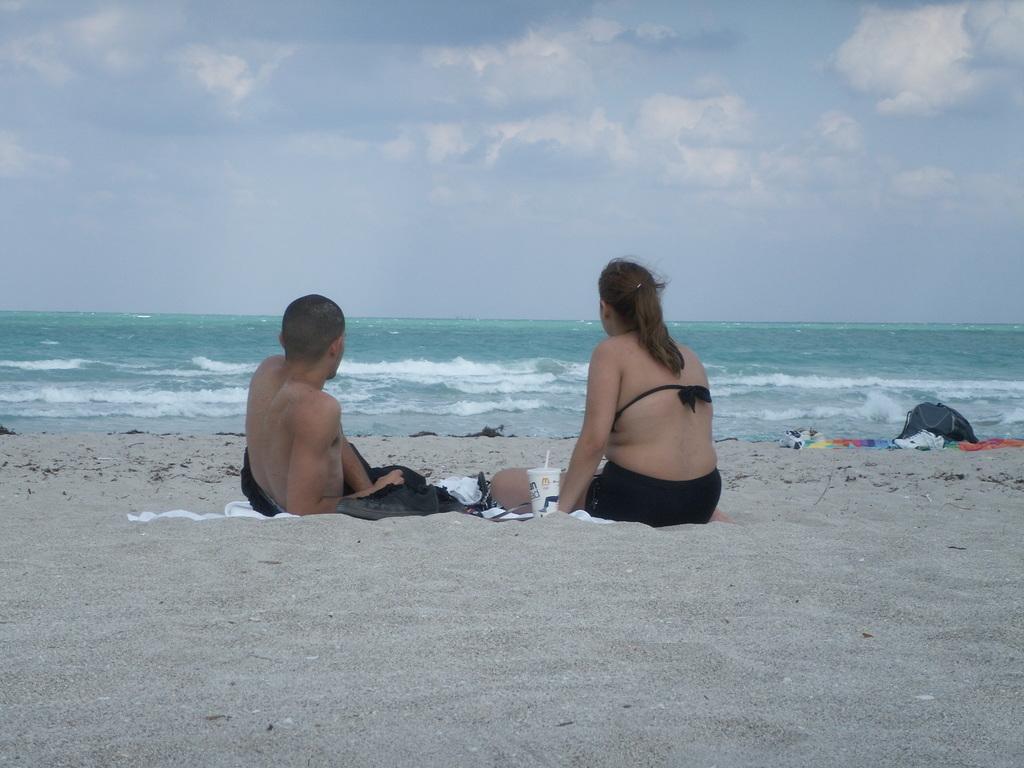How would you summarize this image in a sentence or two? In this image there is a man and a woman sitting on the ground. Beside the woman there is a glass on the ground. In front of them there is the water. At the top there is the sky. To the right there is a bag on the ground. 